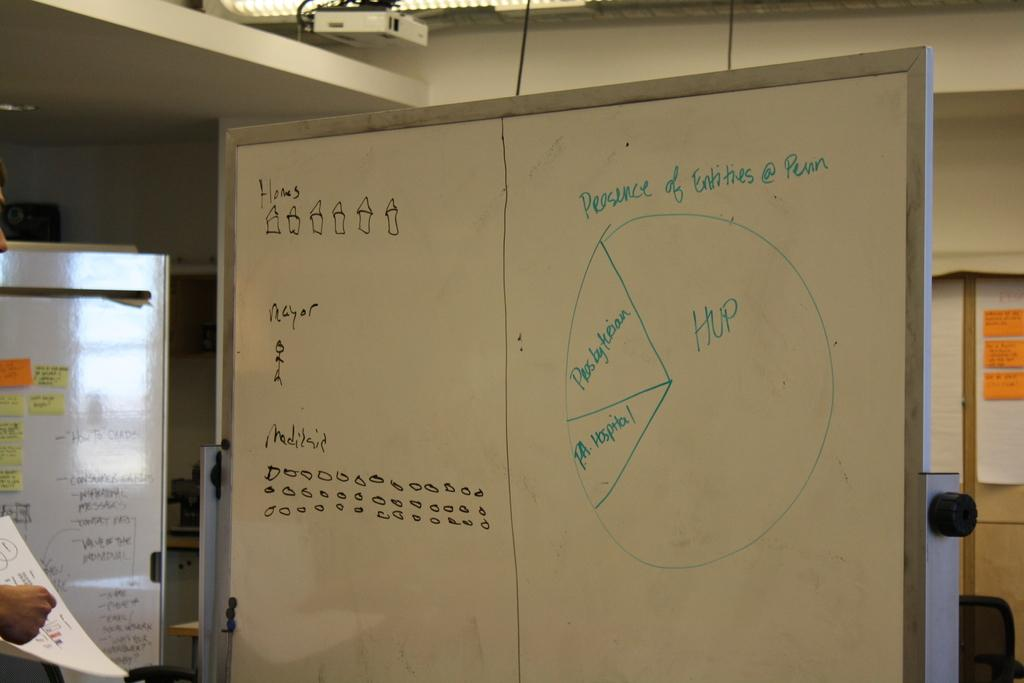Provide a one-sentence caption for the provided image. A white board with the words presence of entities written above a pie chart. 